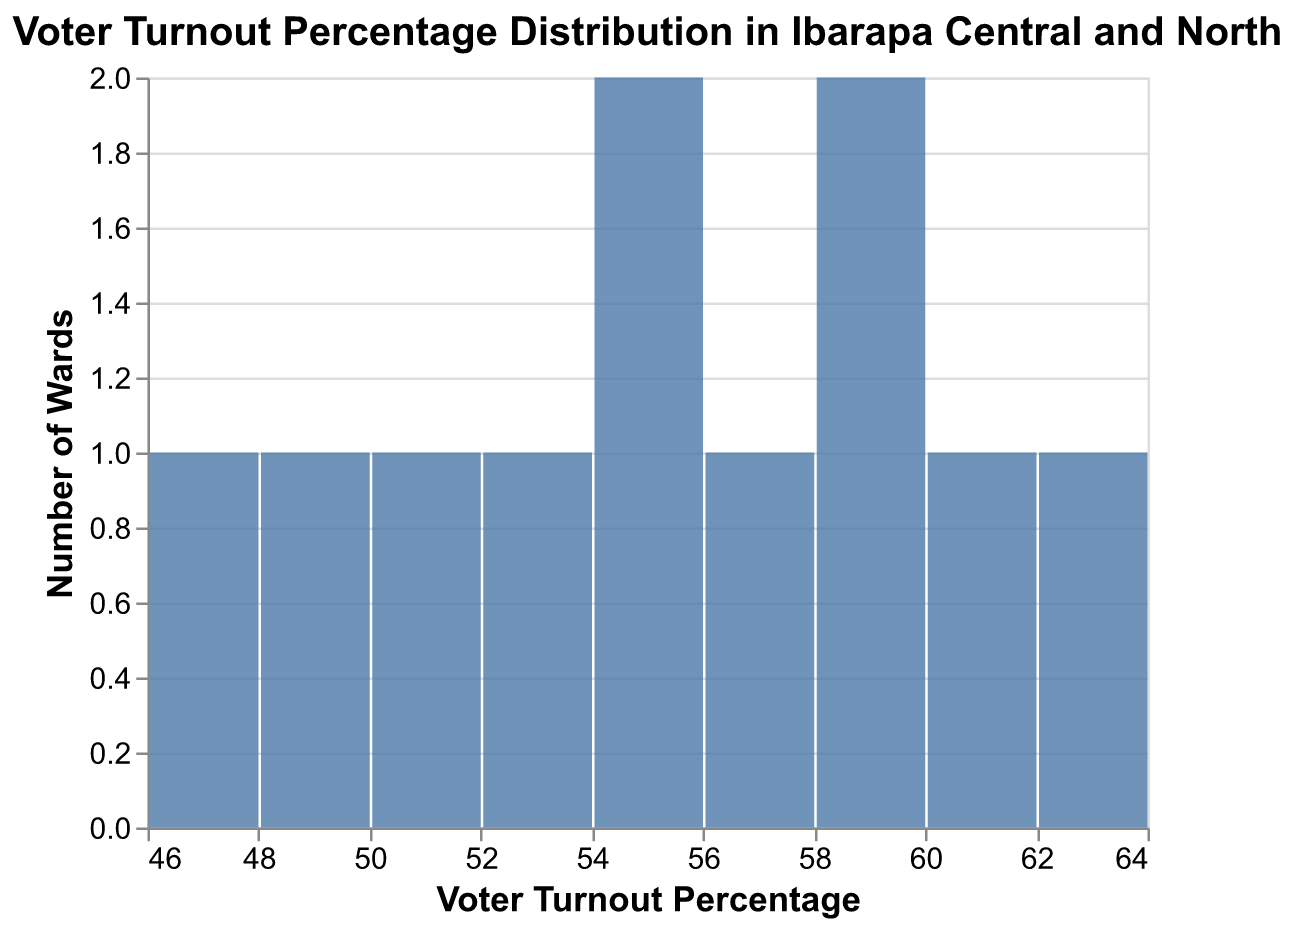What's the title of the chart? The title is displayed at the top of the chart, it is usually descriptive of the content being plotted.
Answer: Voter Turnout Percentage Distribution in Ibarapa Central and North What is the color of the bars in the chart? The color of the bars can be observed directly from their appearance in the plot.
Answer: Blue How many wards have a voter turnout percentage between 50% and 60%? To find this, count the number of bars in the histogram that fall within the 50-60% bin.
Answer: 5 What is the range of voter turnout percentages displayed on the x-axis? The x-axis shows the range of voter turnout percentages plotted.
Answer: 45% to 65% Which ward has the highest voter turnout percentage? Look at the ward with the highest voter turnout percentage in the data.
Answer: Igangan I How many wards have a voter turnout percentage less than 50%? Count the number of wards with voter turnout percentage values below 50% from the data.
Answer: 2 What is the mean voter turnout percentage across all wards? Calculate the mean by summing all voter turnout percentages and dividing by the number of wards: (55.3 + 48.7 + 59.1 + 52.4 + 61.2 + 57.6 + 50.9 + 46.3 + 54.0 + 63.5 + 58.1) / 11.
Answer: 55.6 How many bins are used in the chart? Count the number of distinct bins shown on the x-axis.
Answer: 7 Which voter turnout percentage bin has the highest number of wards? Identify the bar that reaches the highest point on the y-axis.
Answer: 55% - 60% Are there more wards with a voter turnout percentage above or below 55%? Compare the count of wards with voter turnout percentage above 55% to those below 55%, using the data as reference.
Answer: Above 55% 